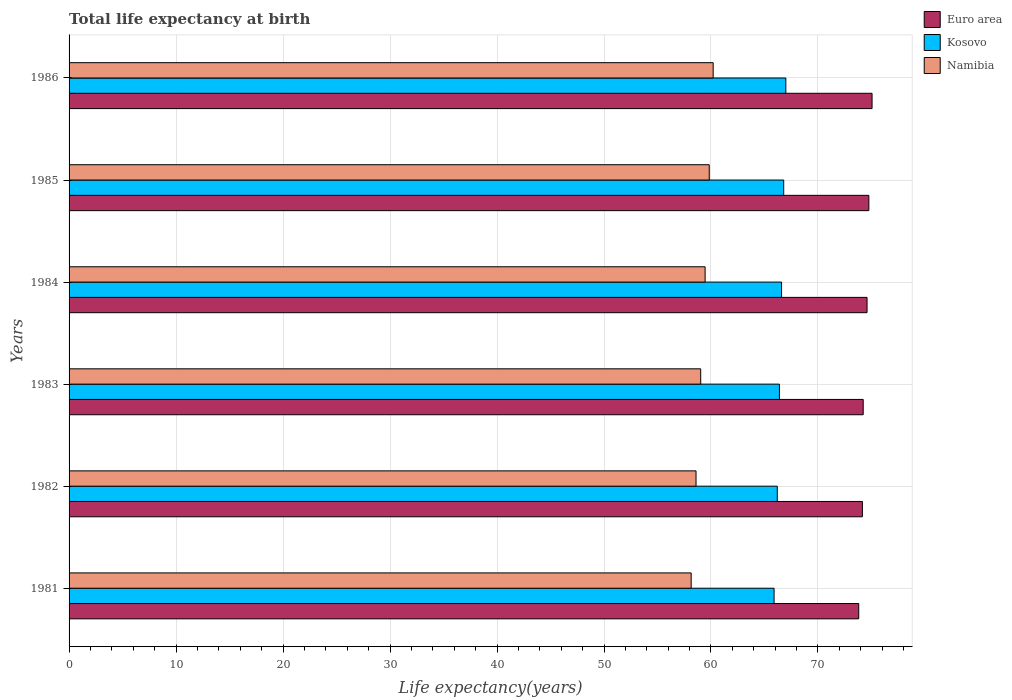How many different coloured bars are there?
Provide a short and direct response. 3. Are the number of bars per tick equal to the number of legend labels?
Give a very brief answer. Yes. How many bars are there on the 2nd tick from the top?
Your response must be concise. 3. How many bars are there on the 4th tick from the bottom?
Make the answer very short. 3. In how many cases, is the number of bars for a given year not equal to the number of legend labels?
Your answer should be very brief. 0. What is the life expectancy at birth in in Euro area in 1983?
Provide a succinct answer. 74.23. Across all years, what is the maximum life expectancy at birth in in Namibia?
Offer a very short reply. 60.2. Across all years, what is the minimum life expectancy at birth in in Namibia?
Ensure brevity in your answer.  58.15. In which year was the life expectancy at birth in in Euro area maximum?
Give a very brief answer. 1986. What is the total life expectancy at birth in in Kosovo in the graph?
Give a very brief answer. 398.89. What is the difference between the life expectancy at birth in in Namibia in 1981 and that in 1983?
Provide a succinct answer. -0.89. What is the difference between the life expectancy at birth in in Euro area in 1981 and the life expectancy at birth in in Kosovo in 1986?
Provide a short and direct response. 6.81. What is the average life expectancy at birth in in Kosovo per year?
Keep it short and to the point. 66.48. In the year 1985, what is the difference between the life expectancy at birth in in Namibia and life expectancy at birth in in Kosovo?
Give a very brief answer. -6.96. What is the ratio of the life expectancy at birth in in Kosovo in 1982 to that in 1983?
Offer a very short reply. 1. Is the life expectancy at birth in in Kosovo in 1981 less than that in 1986?
Your response must be concise. Yes. Is the difference between the life expectancy at birth in in Namibia in 1981 and 1984 greater than the difference between the life expectancy at birth in in Kosovo in 1981 and 1984?
Make the answer very short. No. What is the difference between the highest and the second highest life expectancy at birth in in Kosovo?
Make the answer very short. 0.2. What is the difference between the highest and the lowest life expectancy at birth in in Namibia?
Offer a terse response. 2.06. Is the sum of the life expectancy at birth in in Kosovo in 1981 and 1984 greater than the maximum life expectancy at birth in in Namibia across all years?
Offer a very short reply. Yes. What does the 3rd bar from the bottom in 1984 represents?
Your response must be concise. Namibia. Is it the case that in every year, the sum of the life expectancy at birth in in Namibia and life expectancy at birth in in Kosovo is greater than the life expectancy at birth in in Euro area?
Your response must be concise. Yes. How many bars are there?
Provide a short and direct response. 18. How many years are there in the graph?
Give a very brief answer. 6. What is the difference between two consecutive major ticks on the X-axis?
Your answer should be very brief. 10. Does the graph contain grids?
Provide a short and direct response. Yes. How many legend labels are there?
Give a very brief answer. 3. What is the title of the graph?
Your answer should be very brief. Total life expectancy at birth. What is the label or title of the X-axis?
Offer a terse response. Life expectancy(years). What is the label or title of the Y-axis?
Provide a succinct answer. Years. What is the Life expectancy(years) in Euro area in 1981?
Provide a succinct answer. 73.81. What is the Life expectancy(years) in Kosovo in 1981?
Offer a terse response. 65.9. What is the Life expectancy(years) in Namibia in 1981?
Your answer should be very brief. 58.15. What is the Life expectancy(years) of Euro area in 1982?
Your response must be concise. 74.15. What is the Life expectancy(years) in Kosovo in 1982?
Your answer should be very brief. 66.2. What is the Life expectancy(years) in Namibia in 1982?
Offer a very short reply. 58.6. What is the Life expectancy(years) in Euro area in 1983?
Ensure brevity in your answer.  74.23. What is the Life expectancy(years) of Kosovo in 1983?
Ensure brevity in your answer.  66.4. What is the Life expectancy(years) of Namibia in 1983?
Provide a short and direct response. 59.04. What is the Life expectancy(years) of Euro area in 1984?
Ensure brevity in your answer.  74.59. What is the Life expectancy(years) in Kosovo in 1984?
Provide a short and direct response. 66.6. What is the Life expectancy(years) of Namibia in 1984?
Your response must be concise. 59.45. What is the Life expectancy(years) in Euro area in 1985?
Offer a very short reply. 74.76. What is the Life expectancy(years) in Kosovo in 1985?
Provide a short and direct response. 66.8. What is the Life expectancy(years) of Namibia in 1985?
Your answer should be very brief. 59.84. What is the Life expectancy(years) in Euro area in 1986?
Your response must be concise. 75.06. What is the Life expectancy(years) in Kosovo in 1986?
Offer a very short reply. 67. What is the Life expectancy(years) in Namibia in 1986?
Keep it short and to the point. 60.2. Across all years, what is the maximum Life expectancy(years) in Euro area?
Give a very brief answer. 75.06. Across all years, what is the maximum Life expectancy(years) of Kosovo?
Offer a very short reply. 67. Across all years, what is the maximum Life expectancy(years) of Namibia?
Keep it short and to the point. 60.2. Across all years, what is the minimum Life expectancy(years) of Euro area?
Your response must be concise. 73.81. Across all years, what is the minimum Life expectancy(years) in Kosovo?
Give a very brief answer. 65.9. Across all years, what is the minimum Life expectancy(years) in Namibia?
Provide a succinct answer. 58.15. What is the total Life expectancy(years) in Euro area in the graph?
Ensure brevity in your answer.  446.6. What is the total Life expectancy(years) in Kosovo in the graph?
Your answer should be compact. 398.89. What is the total Life expectancy(years) of Namibia in the graph?
Your response must be concise. 355.29. What is the difference between the Life expectancy(years) of Euro area in 1981 and that in 1982?
Your response must be concise. -0.34. What is the difference between the Life expectancy(years) of Kosovo in 1981 and that in 1982?
Give a very brief answer. -0.3. What is the difference between the Life expectancy(years) in Namibia in 1981 and that in 1982?
Your answer should be compact. -0.45. What is the difference between the Life expectancy(years) in Euro area in 1981 and that in 1983?
Make the answer very short. -0.42. What is the difference between the Life expectancy(years) in Kosovo in 1981 and that in 1983?
Your response must be concise. -0.5. What is the difference between the Life expectancy(years) of Namibia in 1981 and that in 1983?
Offer a very short reply. -0.89. What is the difference between the Life expectancy(years) in Euro area in 1981 and that in 1984?
Make the answer very short. -0.78. What is the difference between the Life expectancy(years) of Namibia in 1981 and that in 1984?
Make the answer very short. -1.3. What is the difference between the Life expectancy(years) of Euro area in 1981 and that in 1985?
Your response must be concise. -0.95. What is the difference between the Life expectancy(years) of Kosovo in 1981 and that in 1985?
Your answer should be very brief. -0.9. What is the difference between the Life expectancy(years) of Namibia in 1981 and that in 1985?
Make the answer very short. -1.69. What is the difference between the Life expectancy(years) in Euro area in 1981 and that in 1986?
Give a very brief answer. -1.25. What is the difference between the Life expectancy(years) of Kosovo in 1981 and that in 1986?
Provide a succinct answer. -1.1. What is the difference between the Life expectancy(years) in Namibia in 1981 and that in 1986?
Provide a succinct answer. -2.06. What is the difference between the Life expectancy(years) of Euro area in 1982 and that in 1983?
Give a very brief answer. -0.08. What is the difference between the Life expectancy(years) in Kosovo in 1982 and that in 1983?
Your answer should be very brief. -0.2. What is the difference between the Life expectancy(years) in Namibia in 1982 and that in 1983?
Provide a succinct answer. -0.44. What is the difference between the Life expectancy(years) of Euro area in 1982 and that in 1984?
Give a very brief answer. -0.43. What is the difference between the Life expectancy(years) in Kosovo in 1982 and that in 1984?
Provide a succinct answer. -0.4. What is the difference between the Life expectancy(years) in Namibia in 1982 and that in 1984?
Provide a succinct answer. -0.85. What is the difference between the Life expectancy(years) of Euro area in 1982 and that in 1985?
Your answer should be compact. -0.6. What is the difference between the Life expectancy(years) of Namibia in 1982 and that in 1985?
Give a very brief answer. -1.24. What is the difference between the Life expectancy(years) of Euro area in 1982 and that in 1986?
Give a very brief answer. -0.9. What is the difference between the Life expectancy(years) in Namibia in 1982 and that in 1986?
Offer a terse response. -1.6. What is the difference between the Life expectancy(years) in Euro area in 1983 and that in 1984?
Give a very brief answer. -0.36. What is the difference between the Life expectancy(years) in Kosovo in 1983 and that in 1984?
Provide a short and direct response. -0.2. What is the difference between the Life expectancy(years) in Namibia in 1983 and that in 1984?
Your response must be concise. -0.41. What is the difference between the Life expectancy(years) in Euro area in 1983 and that in 1985?
Provide a short and direct response. -0.53. What is the difference between the Life expectancy(years) of Namibia in 1983 and that in 1985?
Your answer should be compact. -0.8. What is the difference between the Life expectancy(years) of Euro area in 1983 and that in 1986?
Keep it short and to the point. -0.83. What is the difference between the Life expectancy(years) of Kosovo in 1983 and that in 1986?
Provide a succinct answer. -0.6. What is the difference between the Life expectancy(years) in Namibia in 1983 and that in 1986?
Make the answer very short. -1.17. What is the difference between the Life expectancy(years) in Euro area in 1984 and that in 1985?
Give a very brief answer. -0.17. What is the difference between the Life expectancy(years) of Namibia in 1984 and that in 1985?
Give a very brief answer. -0.39. What is the difference between the Life expectancy(years) of Euro area in 1984 and that in 1986?
Keep it short and to the point. -0.47. What is the difference between the Life expectancy(years) of Namibia in 1984 and that in 1986?
Provide a short and direct response. -0.75. What is the difference between the Life expectancy(years) in Euro area in 1985 and that in 1986?
Provide a succinct answer. -0.3. What is the difference between the Life expectancy(years) of Kosovo in 1985 and that in 1986?
Offer a very short reply. -0.2. What is the difference between the Life expectancy(years) of Namibia in 1985 and that in 1986?
Ensure brevity in your answer.  -0.37. What is the difference between the Life expectancy(years) in Euro area in 1981 and the Life expectancy(years) in Kosovo in 1982?
Ensure brevity in your answer.  7.61. What is the difference between the Life expectancy(years) of Euro area in 1981 and the Life expectancy(years) of Namibia in 1982?
Keep it short and to the point. 15.21. What is the difference between the Life expectancy(years) of Kosovo in 1981 and the Life expectancy(years) of Namibia in 1982?
Offer a terse response. 7.3. What is the difference between the Life expectancy(years) in Euro area in 1981 and the Life expectancy(years) in Kosovo in 1983?
Offer a terse response. 7.41. What is the difference between the Life expectancy(years) of Euro area in 1981 and the Life expectancy(years) of Namibia in 1983?
Make the answer very short. 14.77. What is the difference between the Life expectancy(years) in Kosovo in 1981 and the Life expectancy(years) in Namibia in 1983?
Provide a short and direct response. 6.86. What is the difference between the Life expectancy(years) in Euro area in 1981 and the Life expectancy(years) in Kosovo in 1984?
Offer a terse response. 7.21. What is the difference between the Life expectancy(years) of Euro area in 1981 and the Life expectancy(years) of Namibia in 1984?
Provide a succinct answer. 14.36. What is the difference between the Life expectancy(years) in Kosovo in 1981 and the Life expectancy(years) in Namibia in 1984?
Offer a terse response. 6.45. What is the difference between the Life expectancy(years) in Euro area in 1981 and the Life expectancy(years) in Kosovo in 1985?
Keep it short and to the point. 7.01. What is the difference between the Life expectancy(years) of Euro area in 1981 and the Life expectancy(years) of Namibia in 1985?
Keep it short and to the point. 13.97. What is the difference between the Life expectancy(years) in Kosovo in 1981 and the Life expectancy(years) in Namibia in 1985?
Give a very brief answer. 6.06. What is the difference between the Life expectancy(years) of Euro area in 1981 and the Life expectancy(years) of Kosovo in 1986?
Offer a terse response. 6.81. What is the difference between the Life expectancy(years) in Euro area in 1981 and the Life expectancy(years) in Namibia in 1986?
Provide a succinct answer. 13.61. What is the difference between the Life expectancy(years) in Kosovo in 1981 and the Life expectancy(years) in Namibia in 1986?
Keep it short and to the point. 5.69. What is the difference between the Life expectancy(years) in Euro area in 1982 and the Life expectancy(years) in Kosovo in 1983?
Ensure brevity in your answer.  7.76. What is the difference between the Life expectancy(years) of Euro area in 1982 and the Life expectancy(years) of Namibia in 1983?
Your answer should be very brief. 15.12. What is the difference between the Life expectancy(years) of Kosovo in 1982 and the Life expectancy(years) of Namibia in 1983?
Your answer should be compact. 7.16. What is the difference between the Life expectancy(years) in Euro area in 1982 and the Life expectancy(years) in Kosovo in 1984?
Keep it short and to the point. 7.56. What is the difference between the Life expectancy(years) of Euro area in 1982 and the Life expectancy(years) of Namibia in 1984?
Give a very brief answer. 14.7. What is the difference between the Life expectancy(years) in Kosovo in 1982 and the Life expectancy(years) in Namibia in 1984?
Offer a terse response. 6.75. What is the difference between the Life expectancy(years) in Euro area in 1982 and the Life expectancy(years) in Kosovo in 1985?
Provide a succinct answer. 7.36. What is the difference between the Life expectancy(years) of Euro area in 1982 and the Life expectancy(years) of Namibia in 1985?
Your answer should be very brief. 14.31. What is the difference between the Life expectancy(years) in Kosovo in 1982 and the Life expectancy(years) in Namibia in 1985?
Your response must be concise. 6.36. What is the difference between the Life expectancy(years) in Euro area in 1982 and the Life expectancy(years) in Kosovo in 1986?
Offer a terse response. 7.16. What is the difference between the Life expectancy(years) in Euro area in 1982 and the Life expectancy(years) in Namibia in 1986?
Keep it short and to the point. 13.95. What is the difference between the Life expectancy(years) of Kosovo in 1982 and the Life expectancy(years) of Namibia in 1986?
Give a very brief answer. 5.99. What is the difference between the Life expectancy(years) in Euro area in 1983 and the Life expectancy(years) in Kosovo in 1984?
Make the answer very short. 7.63. What is the difference between the Life expectancy(years) of Euro area in 1983 and the Life expectancy(years) of Namibia in 1984?
Ensure brevity in your answer.  14.78. What is the difference between the Life expectancy(years) in Kosovo in 1983 and the Life expectancy(years) in Namibia in 1984?
Offer a terse response. 6.95. What is the difference between the Life expectancy(years) of Euro area in 1983 and the Life expectancy(years) of Kosovo in 1985?
Provide a succinct answer. 7.43. What is the difference between the Life expectancy(years) in Euro area in 1983 and the Life expectancy(years) in Namibia in 1985?
Ensure brevity in your answer.  14.39. What is the difference between the Life expectancy(years) in Kosovo in 1983 and the Life expectancy(years) in Namibia in 1985?
Give a very brief answer. 6.56. What is the difference between the Life expectancy(years) in Euro area in 1983 and the Life expectancy(years) in Kosovo in 1986?
Keep it short and to the point. 7.23. What is the difference between the Life expectancy(years) in Euro area in 1983 and the Life expectancy(years) in Namibia in 1986?
Ensure brevity in your answer.  14.02. What is the difference between the Life expectancy(years) of Kosovo in 1983 and the Life expectancy(years) of Namibia in 1986?
Offer a very short reply. 6.19. What is the difference between the Life expectancy(years) in Euro area in 1984 and the Life expectancy(years) in Kosovo in 1985?
Offer a terse response. 7.79. What is the difference between the Life expectancy(years) in Euro area in 1984 and the Life expectancy(years) in Namibia in 1985?
Your answer should be compact. 14.75. What is the difference between the Life expectancy(years) in Kosovo in 1984 and the Life expectancy(years) in Namibia in 1985?
Your answer should be compact. 6.76. What is the difference between the Life expectancy(years) in Euro area in 1984 and the Life expectancy(years) in Kosovo in 1986?
Ensure brevity in your answer.  7.59. What is the difference between the Life expectancy(years) of Euro area in 1984 and the Life expectancy(years) of Namibia in 1986?
Ensure brevity in your answer.  14.38. What is the difference between the Life expectancy(years) in Kosovo in 1984 and the Life expectancy(years) in Namibia in 1986?
Make the answer very short. 6.39. What is the difference between the Life expectancy(years) of Euro area in 1985 and the Life expectancy(years) of Kosovo in 1986?
Ensure brevity in your answer.  7.76. What is the difference between the Life expectancy(years) of Euro area in 1985 and the Life expectancy(years) of Namibia in 1986?
Your response must be concise. 14.55. What is the difference between the Life expectancy(years) in Kosovo in 1985 and the Life expectancy(years) in Namibia in 1986?
Your response must be concise. 6.59. What is the average Life expectancy(years) of Euro area per year?
Provide a short and direct response. 74.43. What is the average Life expectancy(years) of Kosovo per year?
Provide a short and direct response. 66.48. What is the average Life expectancy(years) in Namibia per year?
Provide a short and direct response. 59.21. In the year 1981, what is the difference between the Life expectancy(years) of Euro area and Life expectancy(years) of Kosovo?
Ensure brevity in your answer.  7.91. In the year 1981, what is the difference between the Life expectancy(years) of Euro area and Life expectancy(years) of Namibia?
Your answer should be very brief. 15.66. In the year 1981, what is the difference between the Life expectancy(years) of Kosovo and Life expectancy(years) of Namibia?
Keep it short and to the point. 7.75. In the year 1982, what is the difference between the Life expectancy(years) in Euro area and Life expectancy(years) in Kosovo?
Make the answer very short. 7.96. In the year 1982, what is the difference between the Life expectancy(years) of Euro area and Life expectancy(years) of Namibia?
Offer a very short reply. 15.55. In the year 1982, what is the difference between the Life expectancy(years) of Kosovo and Life expectancy(years) of Namibia?
Give a very brief answer. 7.6. In the year 1983, what is the difference between the Life expectancy(years) of Euro area and Life expectancy(years) of Kosovo?
Give a very brief answer. 7.83. In the year 1983, what is the difference between the Life expectancy(years) of Euro area and Life expectancy(years) of Namibia?
Offer a terse response. 15.19. In the year 1983, what is the difference between the Life expectancy(years) of Kosovo and Life expectancy(years) of Namibia?
Offer a very short reply. 7.36. In the year 1984, what is the difference between the Life expectancy(years) in Euro area and Life expectancy(years) in Kosovo?
Your response must be concise. 7.99. In the year 1984, what is the difference between the Life expectancy(years) in Euro area and Life expectancy(years) in Namibia?
Your response must be concise. 15.14. In the year 1984, what is the difference between the Life expectancy(years) of Kosovo and Life expectancy(years) of Namibia?
Give a very brief answer. 7.15. In the year 1985, what is the difference between the Life expectancy(years) of Euro area and Life expectancy(years) of Kosovo?
Provide a short and direct response. 7.96. In the year 1985, what is the difference between the Life expectancy(years) of Euro area and Life expectancy(years) of Namibia?
Offer a very short reply. 14.92. In the year 1985, what is the difference between the Life expectancy(years) in Kosovo and Life expectancy(years) in Namibia?
Offer a very short reply. 6.96. In the year 1986, what is the difference between the Life expectancy(years) of Euro area and Life expectancy(years) of Kosovo?
Ensure brevity in your answer.  8.06. In the year 1986, what is the difference between the Life expectancy(years) of Euro area and Life expectancy(years) of Namibia?
Your answer should be compact. 14.85. In the year 1986, what is the difference between the Life expectancy(years) of Kosovo and Life expectancy(years) of Namibia?
Make the answer very short. 6.79. What is the ratio of the Life expectancy(years) of Euro area in 1981 to that in 1982?
Ensure brevity in your answer.  1. What is the ratio of the Life expectancy(years) of Namibia in 1981 to that in 1983?
Offer a very short reply. 0.98. What is the ratio of the Life expectancy(years) in Namibia in 1981 to that in 1984?
Keep it short and to the point. 0.98. What is the ratio of the Life expectancy(years) of Euro area in 1981 to that in 1985?
Your response must be concise. 0.99. What is the ratio of the Life expectancy(years) in Kosovo in 1981 to that in 1985?
Provide a succinct answer. 0.99. What is the ratio of the Life expectancy(years) in Namibia in 1981 to that in 1985?
Ensure brevity in your answer.  0.97. What is the ratio of the Life expectancy(years) of Euro area in 1981 to that in 1986?
Keep it short and to the point. 0.98. What is the ratio of the Life expectancy(years) of Kosovo in 1981 to that in 1986?
Your response must be concise. 0.98. What is the ratio of the Life expectancy(years) of Namibia in 1981 to that in 1986?
Give a very brief answer. 0.97. What is the ratio of the Life expectancy(years) in Euro area in 1982 to that in 1983?
Give a very brief answer. 1. What is the ratio of the Life expectancy(years) of Kosovo in 1982 to that in 1983?
Offer a very short reply. 1. What is the ratio of the Life expectancy(years) of Namibia in 1982 to that in 1984?
Offer a very short reply. 0.99. What is the ratio of the Life expectancy(years) in Namibia in 1982 to that in 1985?
Make the answer very short. 0.98. What is the ratio of the Life expectancy(years) of Euro area in 1982 to that in 1986?
Your response must be concise. 0.99. What is the ratio of the Life expectancy(years) in Namibia in 1982 to that in 1986?
Keep it short and to the point. 0.97. What is the ratio of the Life expectancy(years) of Euro area in 1983 to that in 1984?
Offer a terse response. 1. What is the ratio of the Life expectancy(years) in Kosovo in 1983 to that in 1984?
Provide a short and direct response. 1. What is the ratio of the Life expectancy(years) in Kosovo in 1983 to that in 1985?
Ensure brevity in your answer.  0.99. What is the ratio of the Life expectancy(years) of Namibia in 1983 to that in 1985?
Offer a very short reply. 0.99. What is the ratio of the Life expectancy(years) in Namibia in 1983 to that in 1986?
Provide a short and direct response. 0.98. What is the ratio of the Life expectancy(years) in Euro area in 1984 to that in 1985?
Give a very brief answer. 1. What is the ratio of the Life expectancy(years) of Euro area in 1984 to that in 1986?
Offer a terse response. 0.99. What is the ratio of the Life expectancy(years) in Namibia in 1984 to that in 1986?
Your response must be concise. 0.99. What is the ratio of the Life expectancy(years) in Euro area in 1985 to that in 1986?
Your response must be concise. 1. What is the ratio of the Life expectancy(years) of Kosovo in 1985 to that in 1986?
Offer a terse response. 1. What is the difference between the highest and the second highest Life expectancy(years) in Euro area?
Provide a short and direct response. 0.3. What is the difference between the highest and the second highest Life expectancy(years) of Kosovo?
Your answer should be compact. 0.2. What is the difference between the highest and the second highest Life expectancy(years) of Namibia?
Offer a terse response. 0.37. What is the difference between the highest and the lowest Life expectancy(years) of Euro area?
Offer a terse response. 1.25. What is the difference between the highest and the lowest Life expectancy(years) in Kosovo?
Your answer should be compact. 1.1. What is the difference between the highest and the lowest Life expectancy(years) in Namibia?
Offer a terse response. 2.06. 